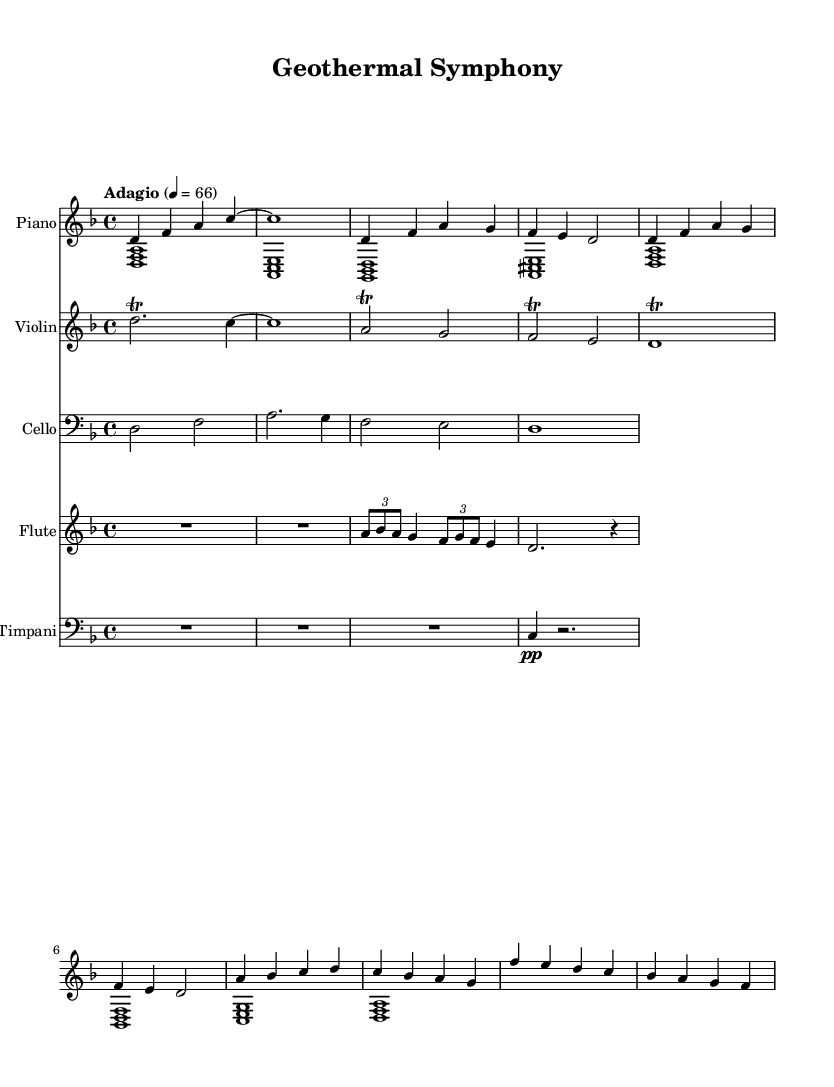What is the key signature of this music? The key signature is indicated at the beginning of the music. In this piece, it is marked with a flat sign, indicating that it is in D minor.
Answer: D minor What is the time signature of this music? The time signature is found at the beginning of the score, where it shows a fraction. In this case, the score displays 4 over 4, meaning there are four beats per measure.
Answer: 4/4 What is the tempo marking of the music? The tempo marking appears at the start of the score and indicates how fast the piece should be played. It shows the tempo as "Adagio" at 66 beats per minute.
Answer: Adagio, 66 Which instruments are featured in this music? The instruments are listed at the beginning of each staff in the sheet music. This piece includes Piano, Violin, Cello, Flute, and Timpani.
Answer: Piano, Violin, Cello, Flute, Timpani How many measures does the piano section contain? To find the number of measures, you count the vertical lines or bar lines in the piano section. The piano section has several measures that can be counted within the notation provided. The total number of visible measures is 10.
Answer: 10 What types of articulations are used in this composition? Articulations are indicated by markings above or below the notes. In this composition, there are trills noted for certain notes, typically in the violin and cello parts, enhancing expressiveness.
Answer: Trills What does the use of dynamics signify in this music? The dynamics, indicated by symbols such as "pp" (pianissimo) and other markings, indicate how loudly or softly each section should be played. This adds to the emotional depth of the atmospheric soundtracks inspired by geothermal landscapes and volcanic activity.
Answer: Emotional depth 